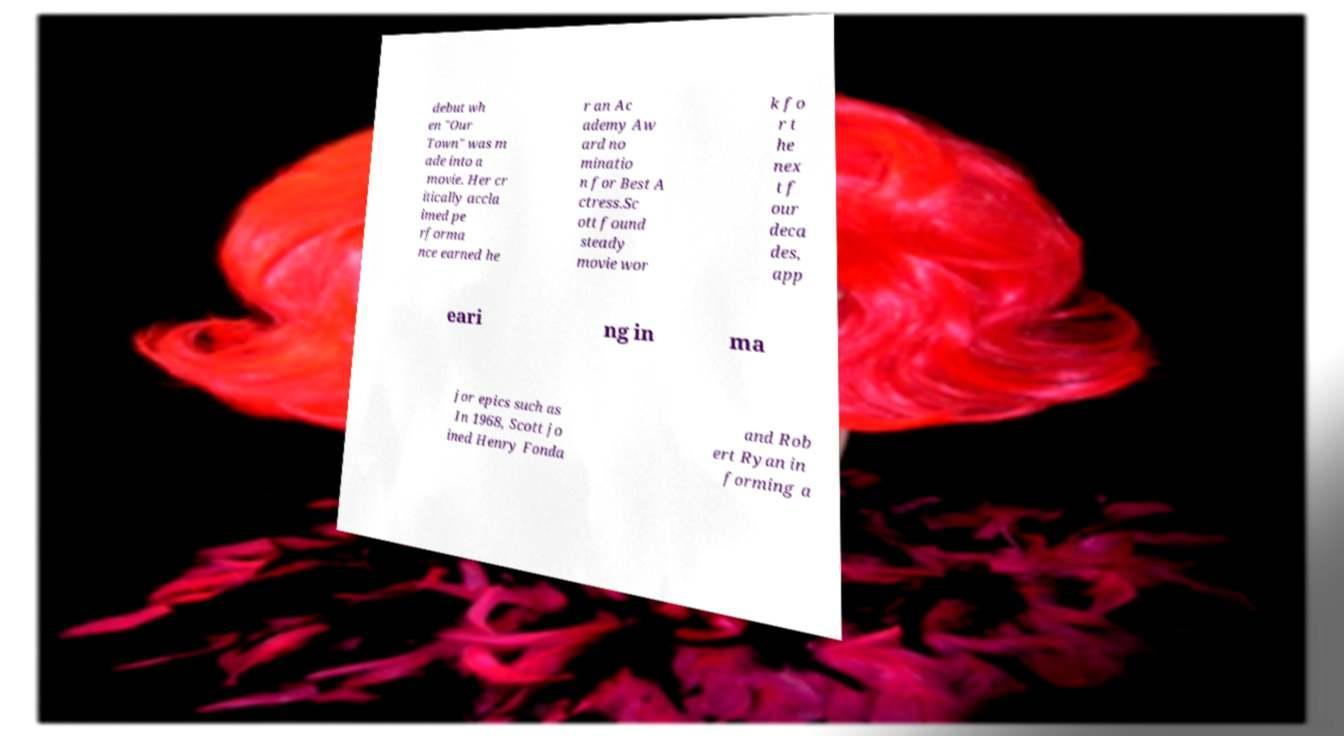What messages or text are displayed in this image? I need them in a readable, typed format. debut wh en "Our Town" was m ade into a movie. Her cr itically accla imed pe rforma nce earned he r an Ac ademy Aw ard no minatio n for Best A ctress.Sc ott found steady movie wor k fo r t he nex t f our deca des, app eari ng in ma jor epics such as In 1968, Scott jo ined Henry Fonda and Rob ert Ryan in forming a 